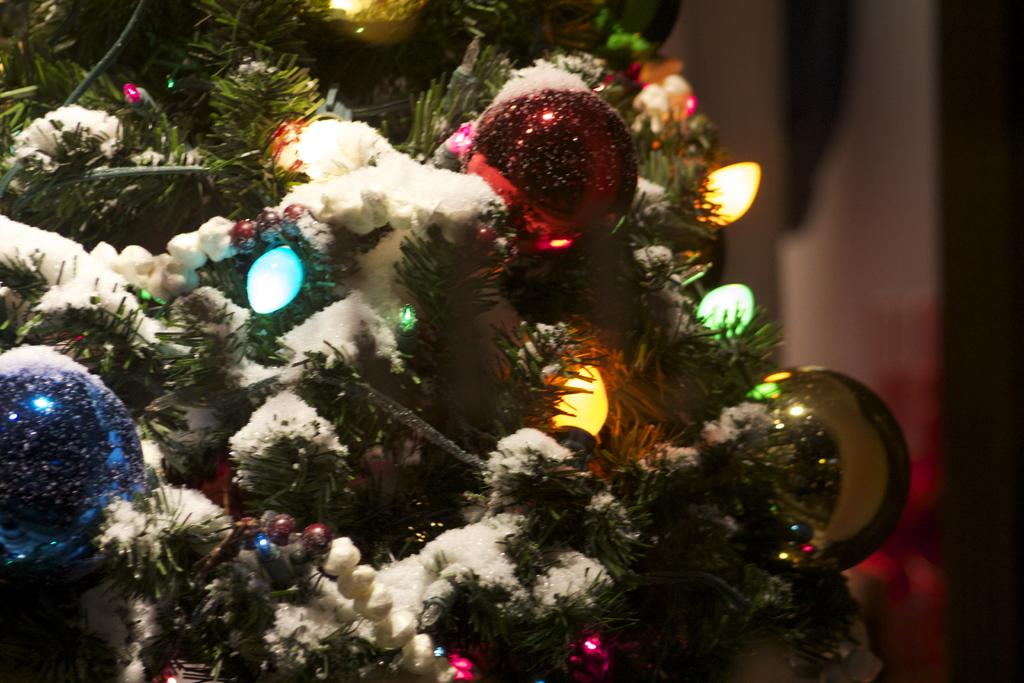What type of tree is decorated in the image? There is a decorated tree with lights in the image. What decorations are on the tree? The tree has colored balls as decorations. What can be seen in the background of the image? There is a wall visible in the image. How many buns are on the field in the image? There are no buns or fields present in the image; it features a decorated tree with lights and colored balls. 